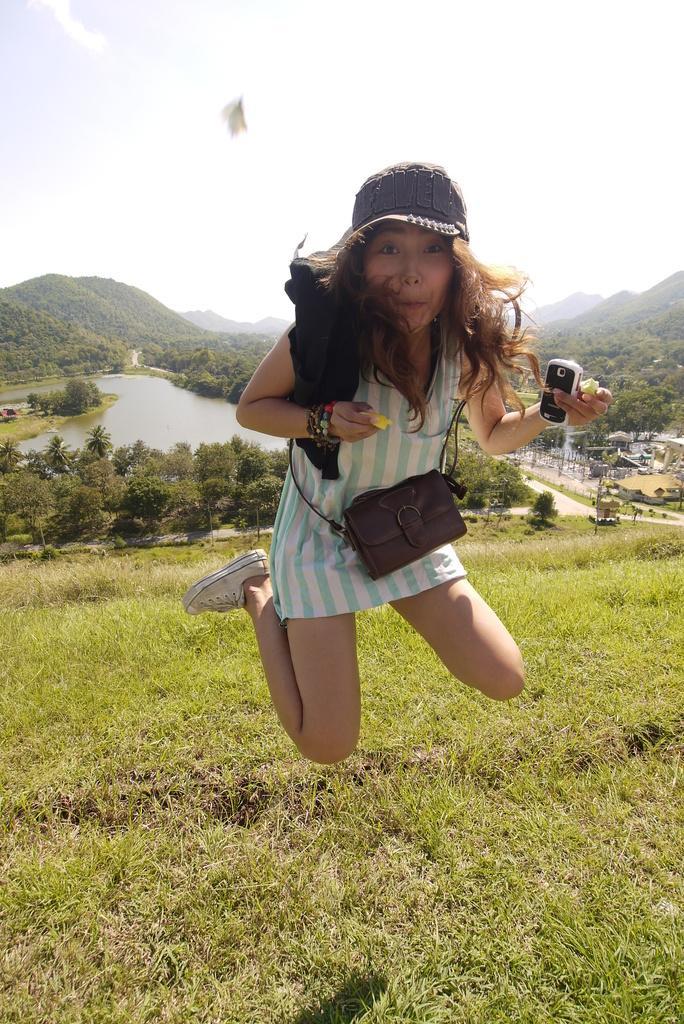How would you summarize this image in a sentence or two? In the middle a woman is jumping in the air and she is wearing a brown color hand bag and hat and holding a mobile in her hand. And a grass visible at the bottom and middle. In the middle mountains are visible and houses are visible and a water visible. On the top sky blue in color is there. This image is taken in the mountain area during day time. 